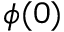<formula> <loc_0><loc_0><loc_500><loc_500>\phi ( 0 )</formula> 